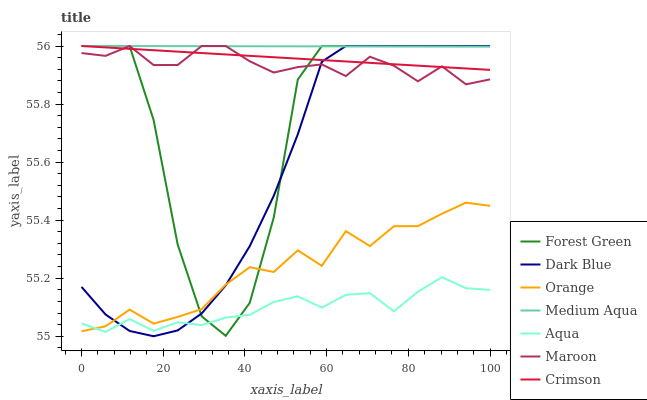Does Aqua have the minimum area under the curve?
Answer yes or no. Yes. Does Medium Aqua have the maximum area under the curve?
Answer yes or no. Yes. Does Maroon have the minimum area under the curve?
Answer yes or no. No. Does Maroon have the maximum area under the curve?
Answer yes or no. No. Is Medium Aqua the smoothest?
Answer yes or no. Yes. Is Forest Green the roughest?
Answer yes or no. Yes. Is Maroon the smoothest?
Answer yes or no. No. Is Maroon the roughest?
Answer yes or no. No. Does Maroon have the lowest value?
Answer yes or no. No. Does Crimson have the highest value?
Answer yes or no. Yes. Does Orange have the highest value?
Answer yes or no. No. Is Aqua less than Maroon?
Answer yes or no. Yes. Is Crimson greater than Aqua?
Answer yes or no. Yes. Does Orange intersect Aqua?
Answer yes or no. Yes. Is Orange less than Aqua?
Answer yes or no. No. Is Orange greater than Aqua?
Answer yes or no. No. Does Aqua intersect Maroon?
Answer yes or no. No. 